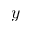Convert formula to latex. <formula><loc_0><loc_0><loc_500><loc_500>y</formula> 